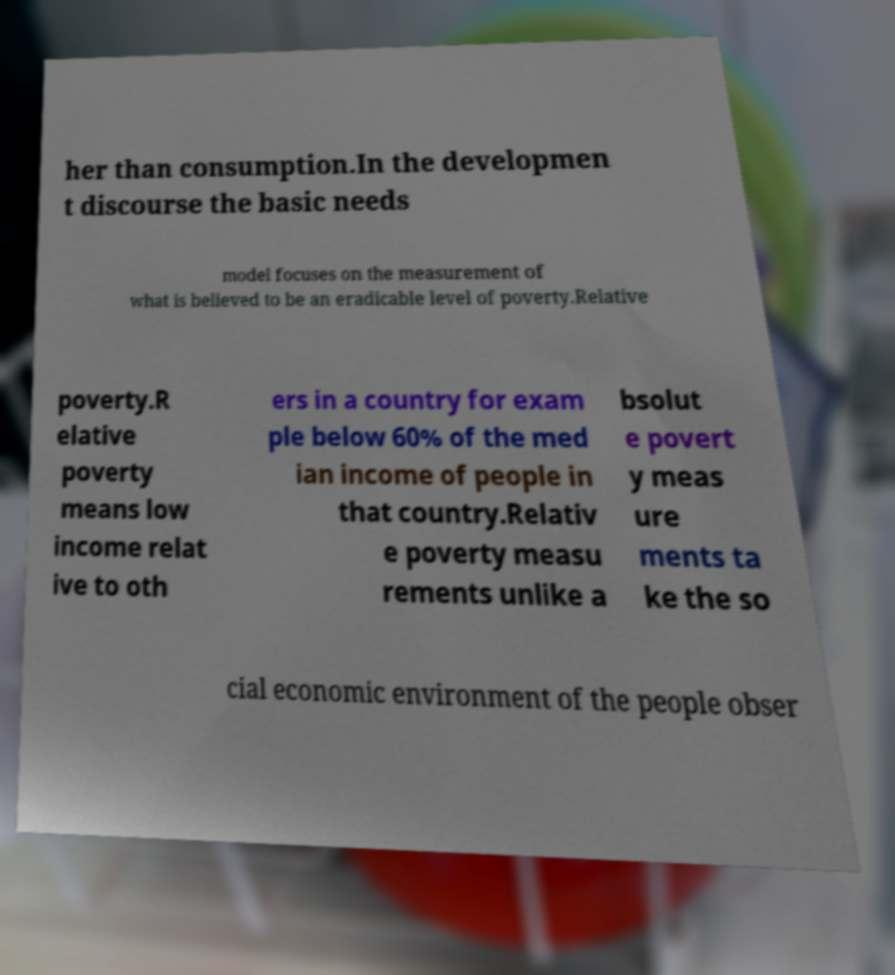For documentation purposes, I need the text within this image transcribed. Could you provide that? her than consumption.In the developmen t discourse the basic needs model focuses on the measurement of what is believed to be an eradicable level of poverty.Relative poverty.R elative poverty means low income relat ive to oth ers in a country for exam ple below 60% of the med ian income of people in that country.Relativ e poverty measu rements unlike a bsolut e povert y meas ure ments ta ke the so cial economic environment of the people obser 